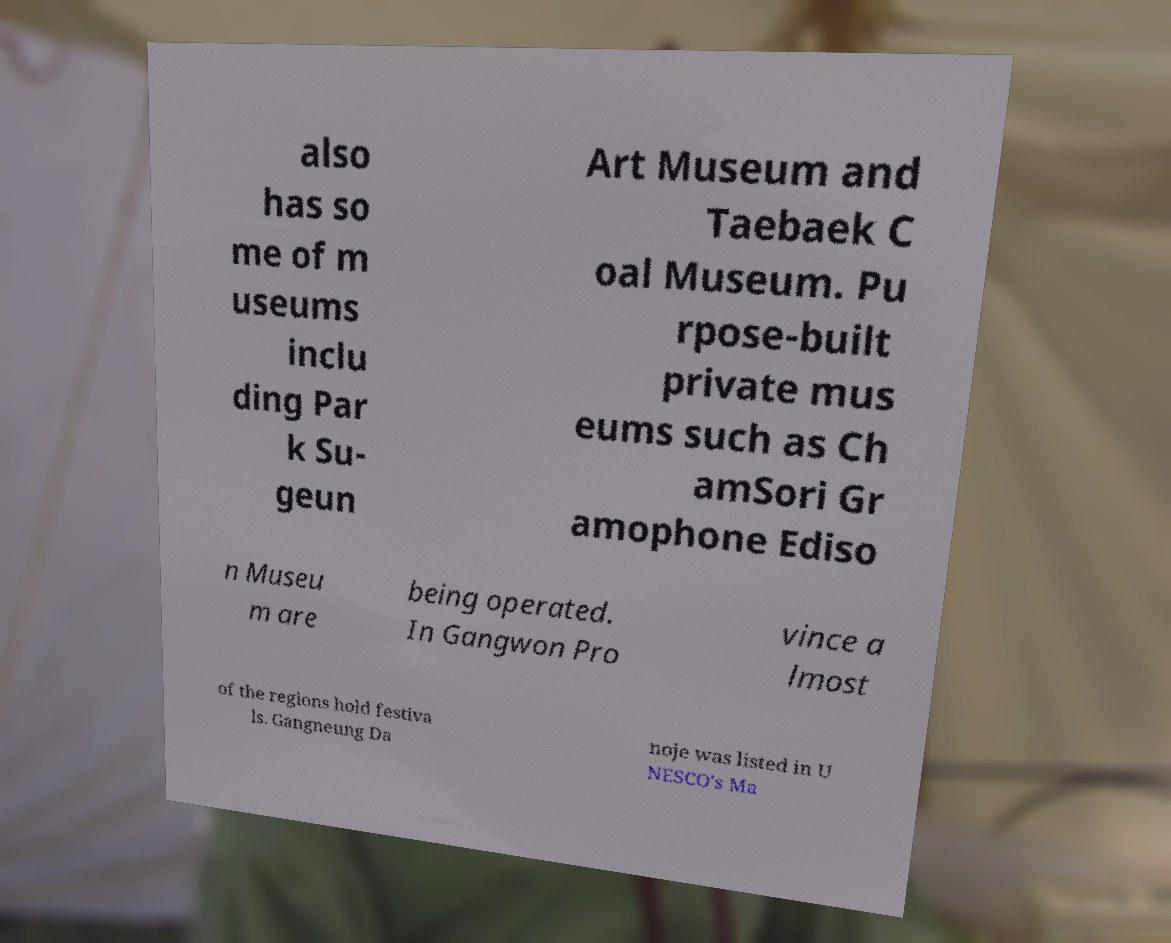There's text embedded in this image that I need extracted. Can you transcribe it verbatim? also has so me of m useums inclu ding Par k Su- geun Art Museum and Taebaek C oal Museum. Pu rpose-built private mus eums such as Ch amSori Gr amophone Ediso n Museu m are being operated. In Gangwon Pro vince a lmost of the regions hold festiva ls. Gangneung Da noje was listed in U NESCO's Ma 